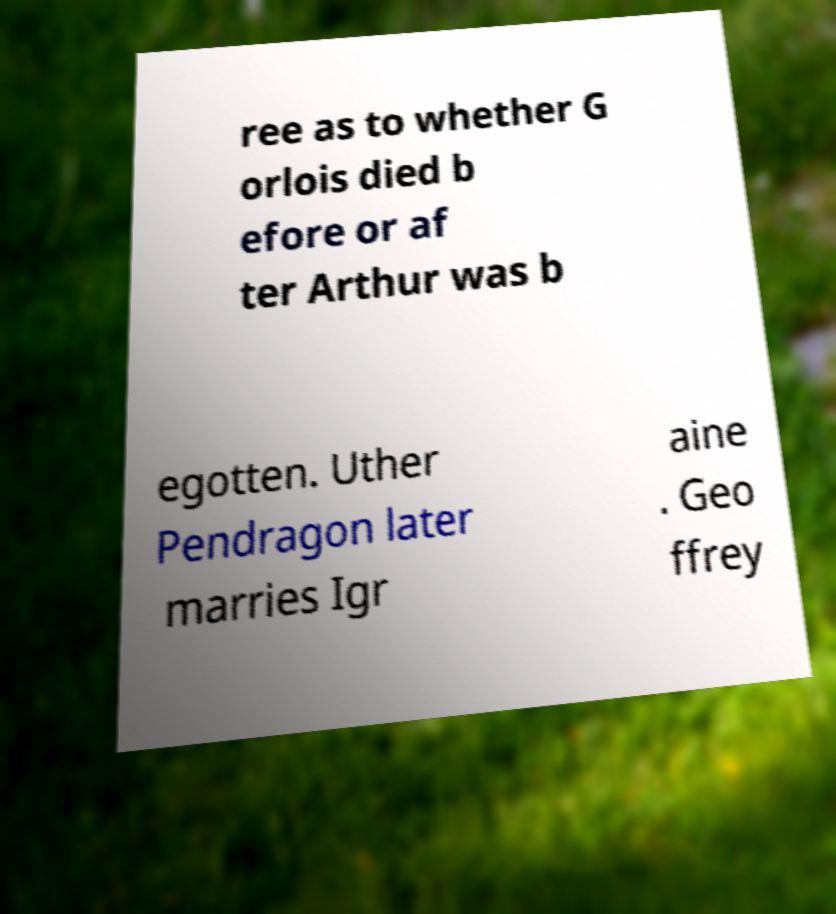Can you read and provide the text displayed in the image?This photo seems to have some interesting text. Can you extract and type it out for me? ree as to whether G orlois died b efore or af ter Arthur was b egotten. Uther Pendragon later marries Igr aine . Geo ffrey 